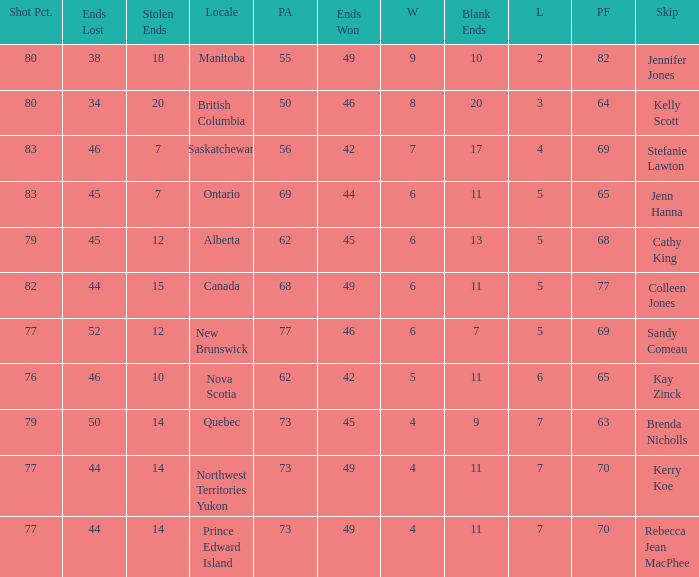What is the minimum PA when ends lost is 45? 62.0. 